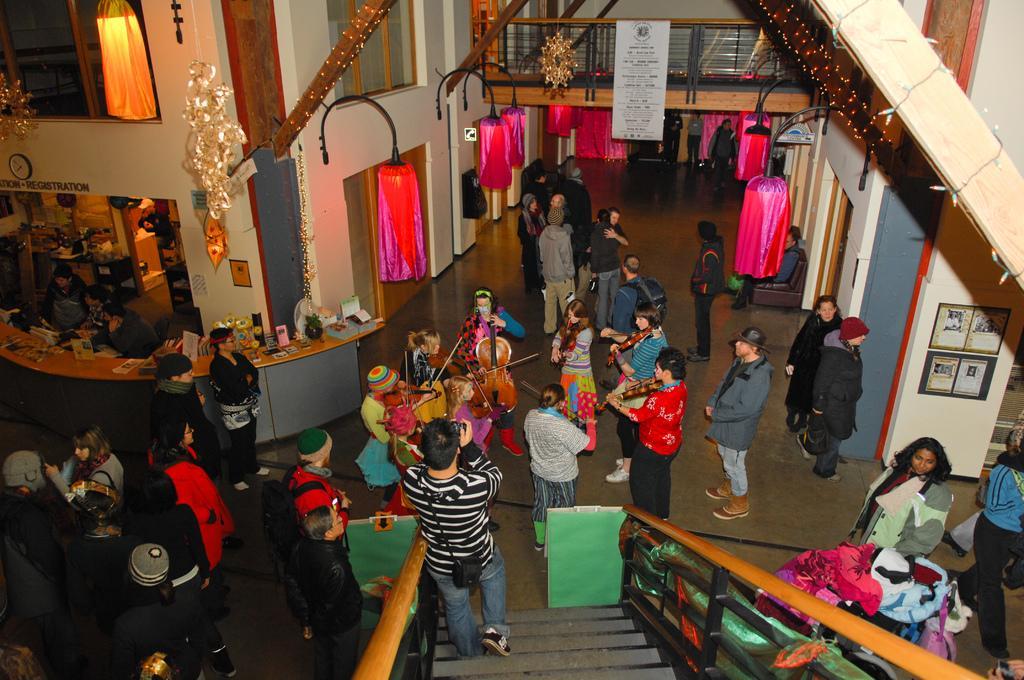Describe this image in one or two sentences. This picture is clicked inside the hall. In the foreground we can see a person wearing sling bag, holding an object and going down the stairs and we can see the handrails, group of persons, we can see the objects hanging on the wall, we can see the picture frames hanging on the wall and we can see the text on the banner, hanging on the railing and we can see the decoration lights and there are some objects placed on the top of the counter and we can see the group of persons seems to be sitting and we can see the group of persons standing and seems to be playing violin and we can see many other objects. 